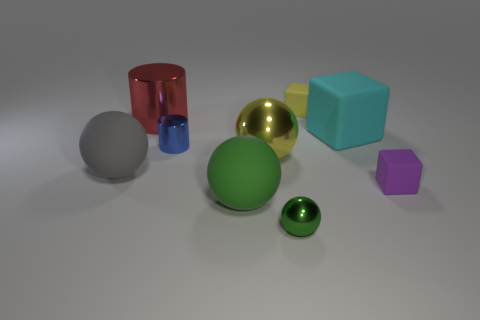Subtract 1 balls. How many balls are left? 3 Add 1 big cyan blocks. How many objects exist? 10 Subtract all spheres. How many objects are left? 5 Subtract all blue things. Subtract all yellow spheres. How many objects are left? 7 Add 5 red cylinders. How many red cylinders are left? 6 Add 2 purple objects. How many purple objects exist? 3 Subtract 0 brown blocks. How many objects are left? 9 